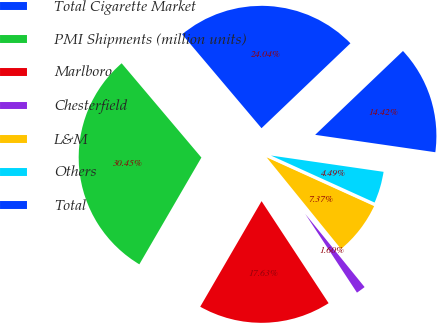Convert chart to OTSL. <chart><loc_0><loc_0><loc_500><loc_500><pie_chart><fcel>Total Cigarette Market<fcel>PMI Shipments (million units)<fcel>Marlboro<fcel>Chesterfield<fcel>L&M<fcel>Others<fcel>Total<nl><fcel>24.04%<fcel>30.45%<fcel>17.63%<fcel>1.6%<fcel>7.37%<fcel>4.49%<fcel>14.42%<nl></chart> 